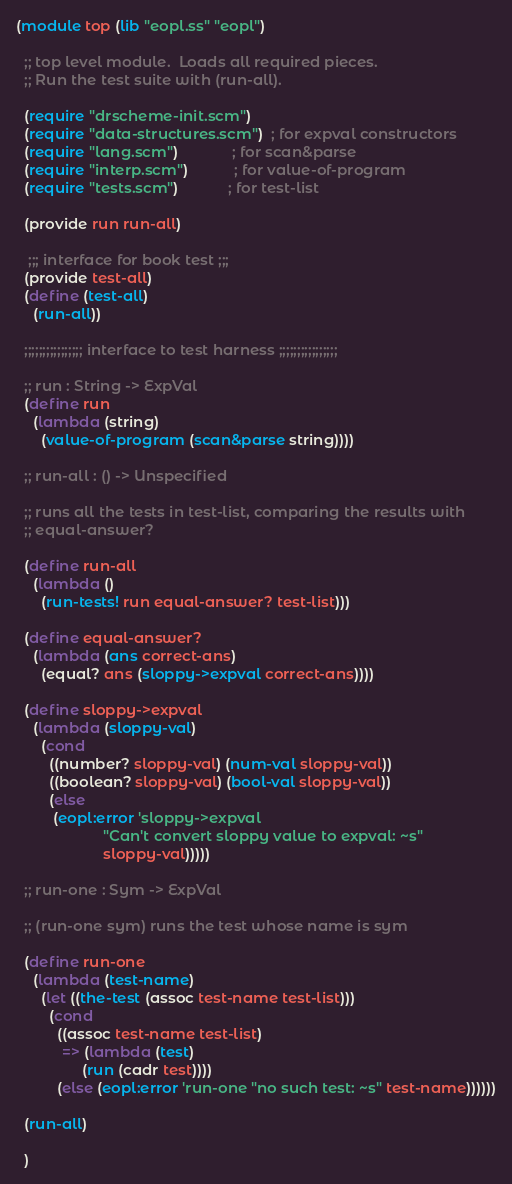Convert code to text. <code><loc_0><loc_0><loc_500><loc_500><_Scheme_>(module top (lib "eopl.ss" "eopl")
  
  ;; top level module.  Loads all required pieces.
  ;; Run the test suite with (run-all).

  (require "drscheme-init.scm")
  (require "data-structures.scm")  ; for expval constructors
  (require "lang.scm")             ; for scan&parse
  (require "interp.scm")           ; for value-of-program
  (require "tests.scm")            ; for test-list
  
  (provide run run-all)
  
   ;;; interface for book test ;;;
  (provide test-all)
  (define (test-all) 
    (run-all))

  ;;;;;;;;;;;;;;;; interface to test harness ;;;;;;;;;;;;;;;;
  
  ;; run : String -> ExpVal
  (define run
    (lambda (string)
      (value-of-program (scan&parse string))))
  
  ;; run-all : () -> Unspecified

  ;; runs all the tests in test-list, comparing the results with
  ;; equal-answer?  

  (define run-all
    (lambda ()
      (run-tests! run equal-answer? test-list)))
  
  (define equal-answer?
    (lambda (ans correct-ans)
      (equal? ans (sloppy->expval correct-ans))))
  
  (define sloppy->expval 
    (lambda (sloppy-val)
      (cond
        ((number? sloppy-val) (num-val sloppy-val))
        ((boolean? sloppy-val) (bool-val sloppy-val))
        (else
         (eopl:error 'sloppy->expval 
                     "Can't convert sloppy value to expval: ~s"
                     sloppy-val)))))
    
  ;; run-one : Sym -> ExpVal

  ;; (run-one sym) runs the test whose name is sym
  
  (define run-one
    (lambda (test-name)
      (let ((the-test (assoc test-name test-list)))
        (cond
          ((assoc test-name test-list)
           => (lambda (test)
                (run (cadr test))))
          (else (eopl:error 'run-one "no such test: ~s" test-name))))))
 
  (run-all)
  
  )






</code> 